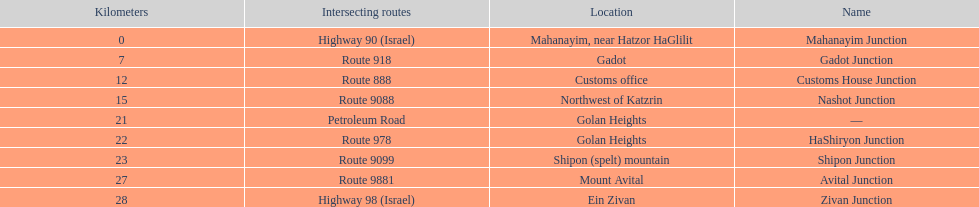What is the total kilometers that separates the mahanayim junction and the shipon junction? 23. 